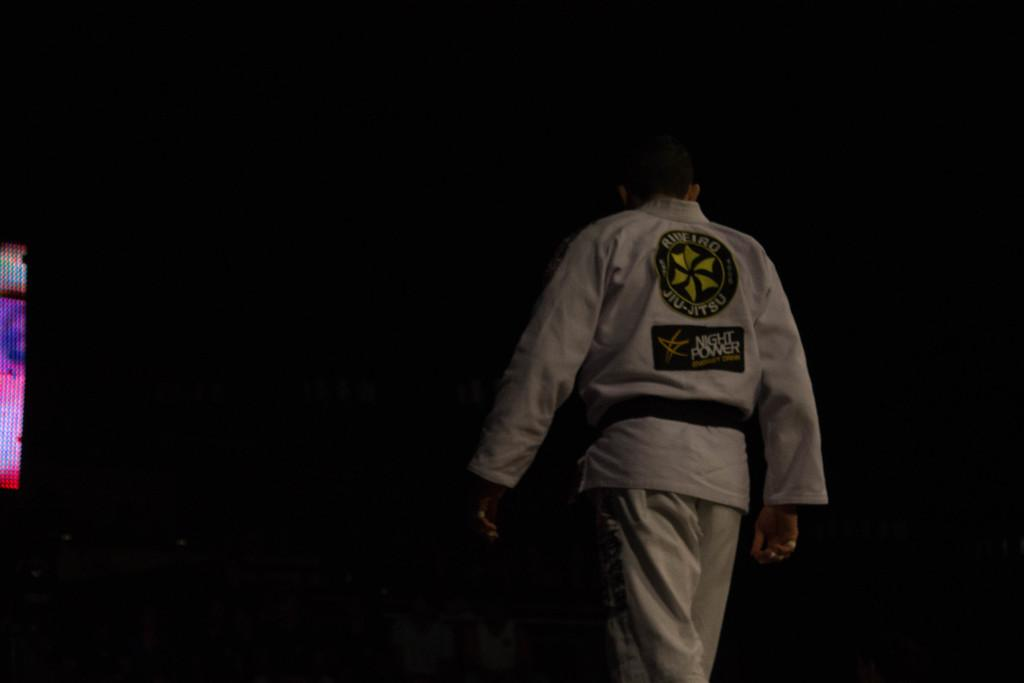<image>
Share a concise interpretation of the image provided. a person with their back to the camera in a suit reading Jiu-Jitsu 